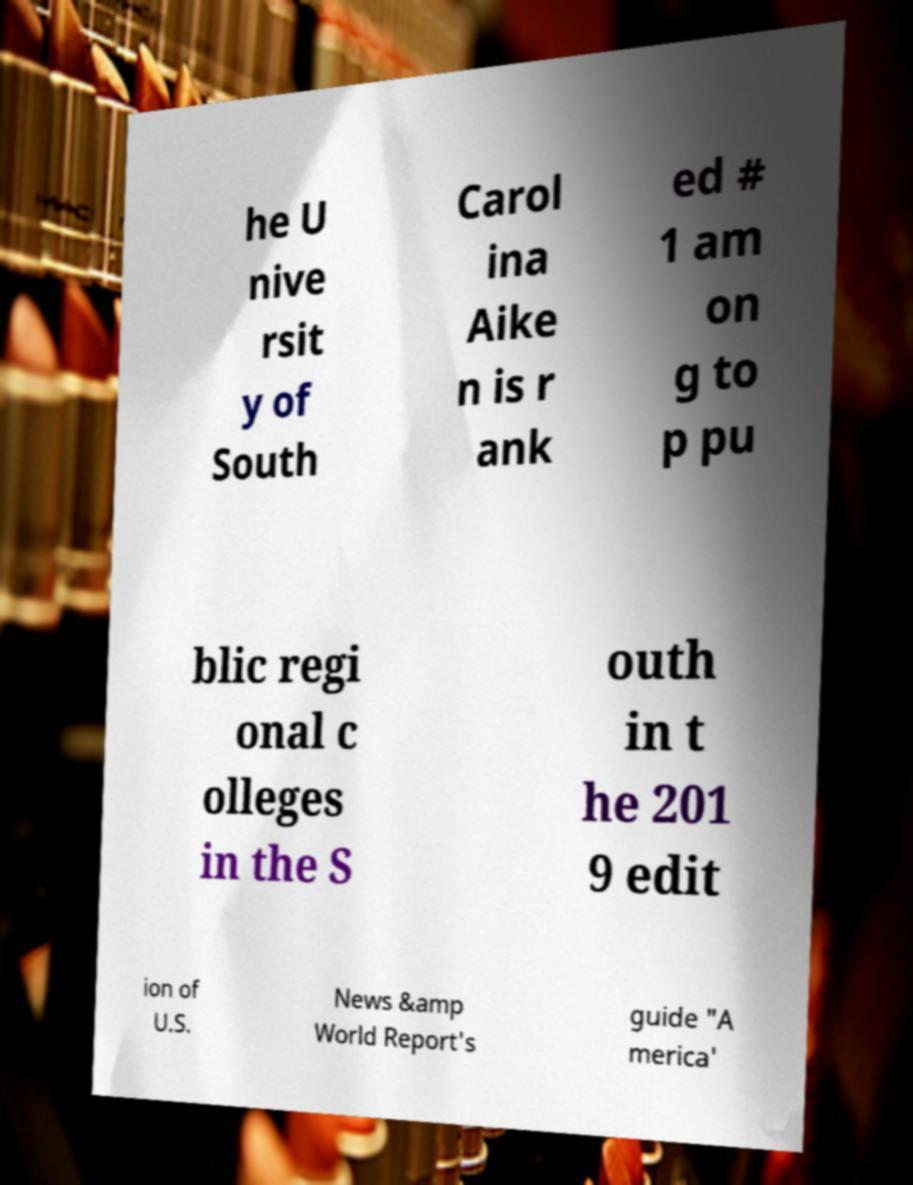Please read and relay the text visible in this image. What does it say? he U nive rsit y of South Carol ina Aike n is r ank ed # 1 am on g to p pu blic regi onal c olleges in the S outh in t he 201 9 edit ion of U.S. News &amp World Report's guide "A merica' 